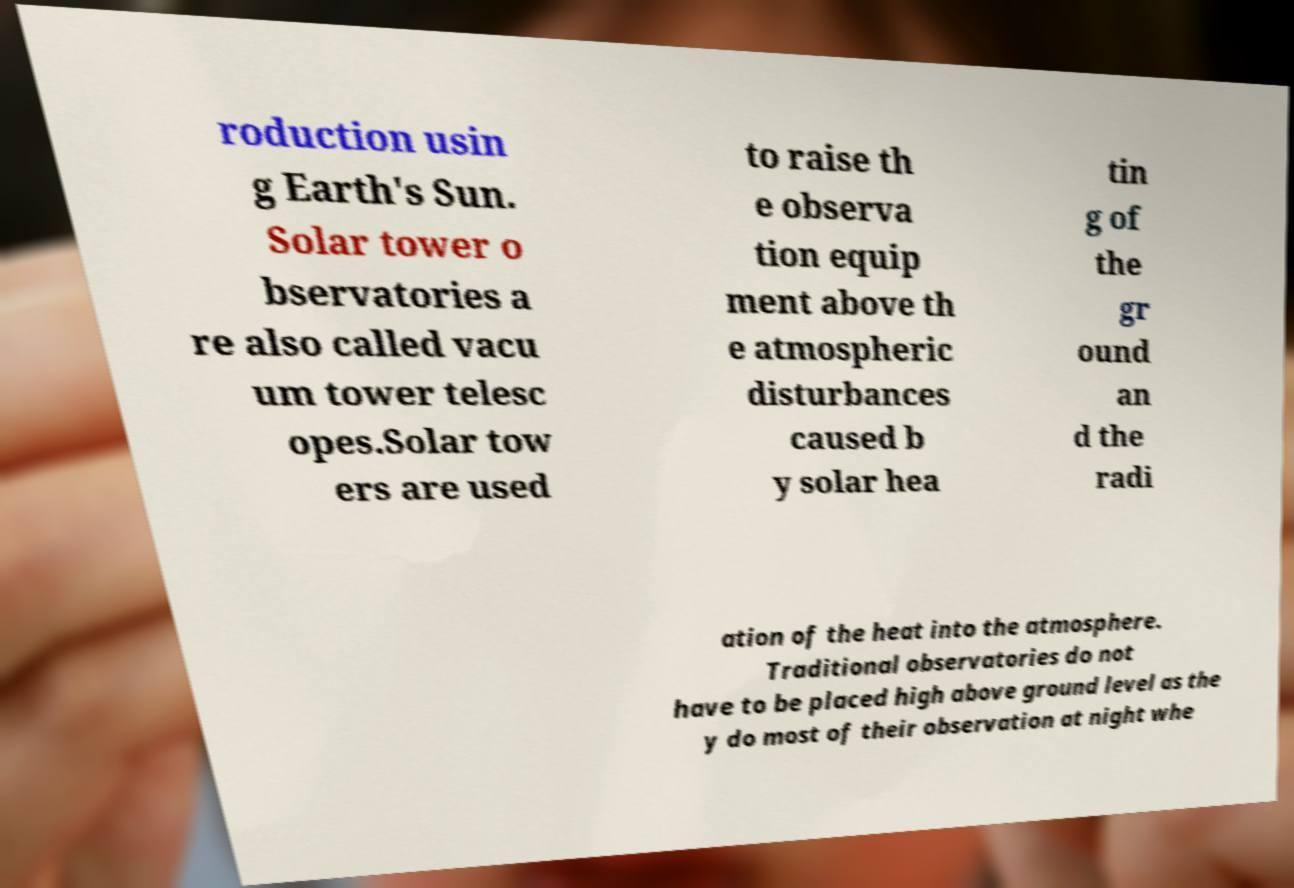I need the written content from this picture converted into text. Can you do that? roduction usin g Earth's Sun. Solar tower o bservatories a re also called vacu um tower telesc opes.Solar tow ers are used to raise th e observa tion equip ment above th e atmospheric disturbances caused b y solar hea tin g of the gr ound an d the radi ation of the heat into the atmosphere. Traditional observatories do not have to be placed high above ground level as the y do most of their observation at night whe 